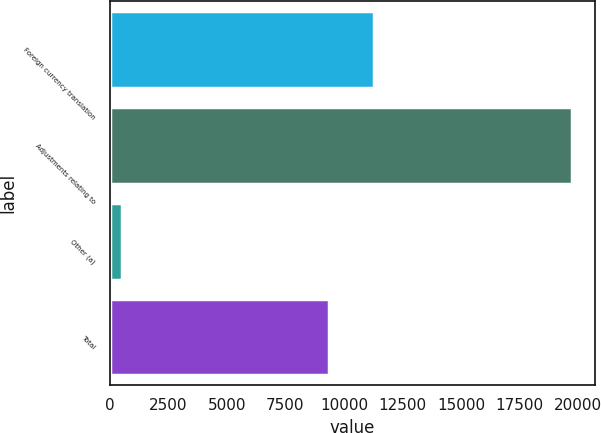<chart> <loc_0><loc_0><loc_500><loc_500><bar_chart><fcel>Foreign currency translation<fcel>Adjustments relating to<fcel>Other (a)<fcel>Total<nl><fcel>11301.7<fcel>19726<fcel>509<fcel>9380<nl></chart> 